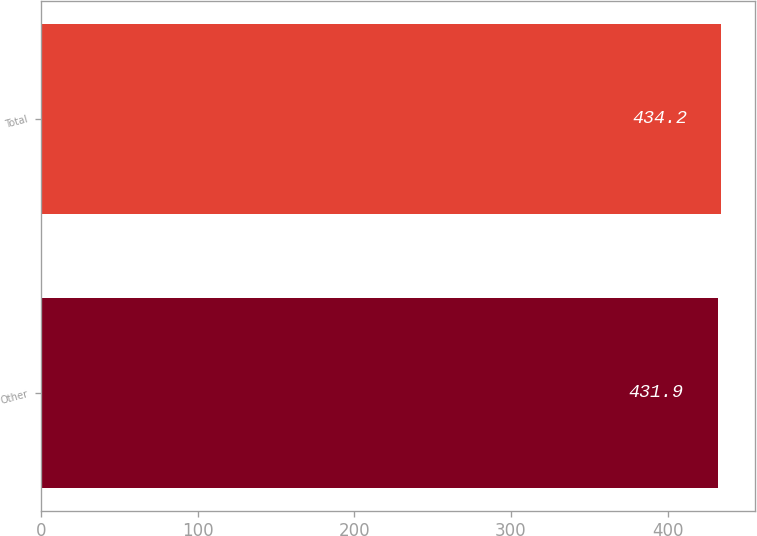Convert chart. <chart><loc_0><loc_0><loc_500><loc_500><bar_chart><fcel>Other<fcel>Total<nl><fcel>431.9<fcel>434.2<nl></chart> 